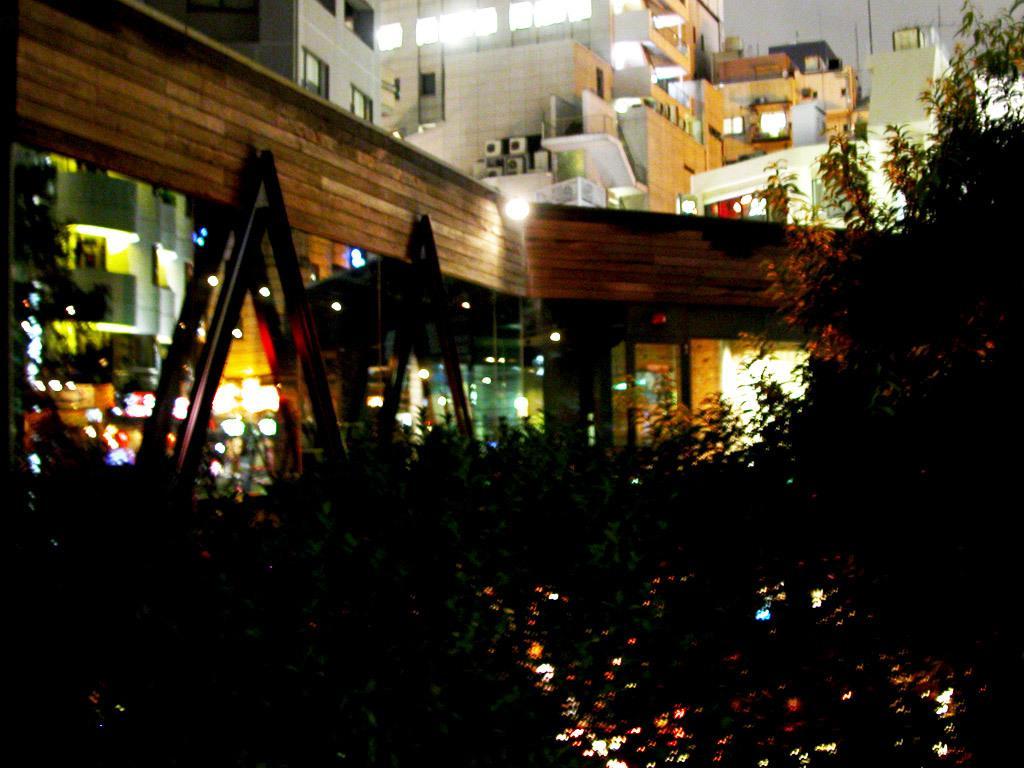How would you summarize this image in a sentence or two? In this image I can see at the bottom there are trees with the lights. At the back side there are buildings with the lights. 